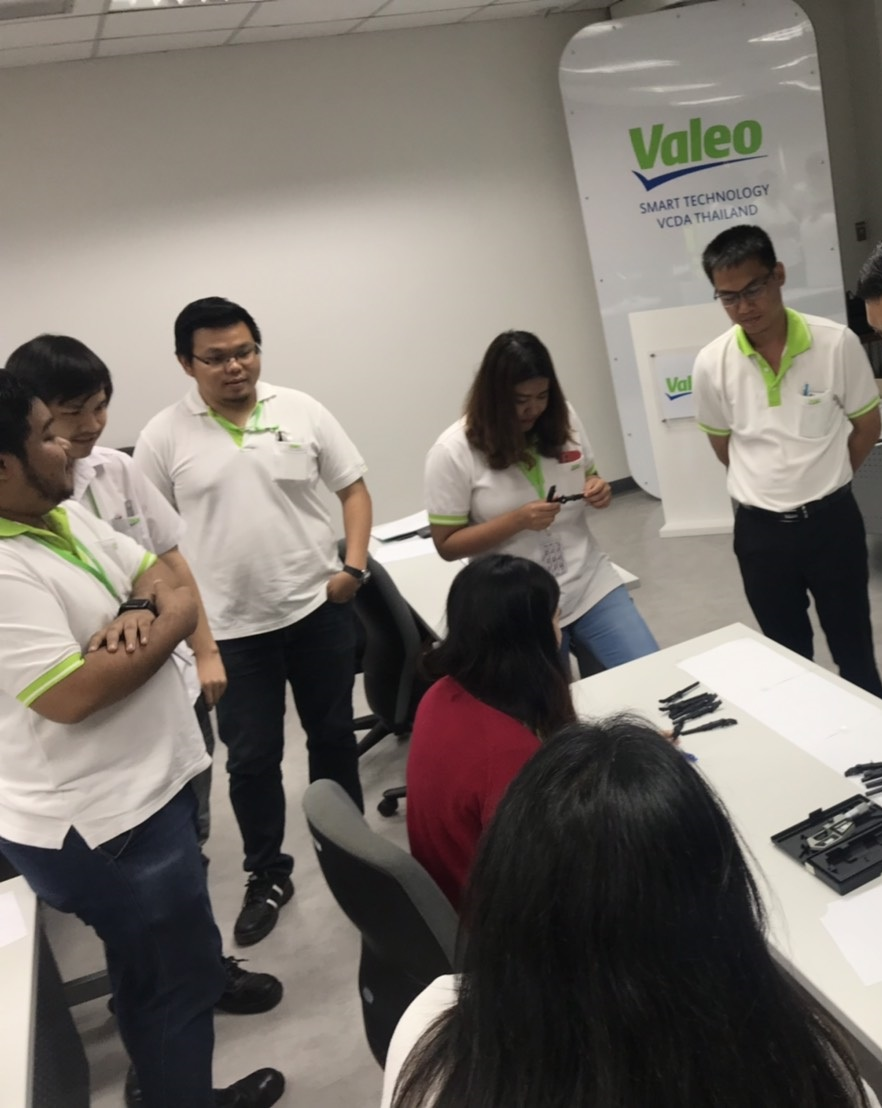What might be the possible outcomes of such a meeting? The outcomes of this meeting could potentially include the development of new ideas or adjustments to existing projects, alignment on team goals, enhanced understanding of technical challenges, and stronger inter-departmental cooperation. The context suggests a focus on generating actionable solutions or strategy mapping to leverage smart technology effectively within their organization. 